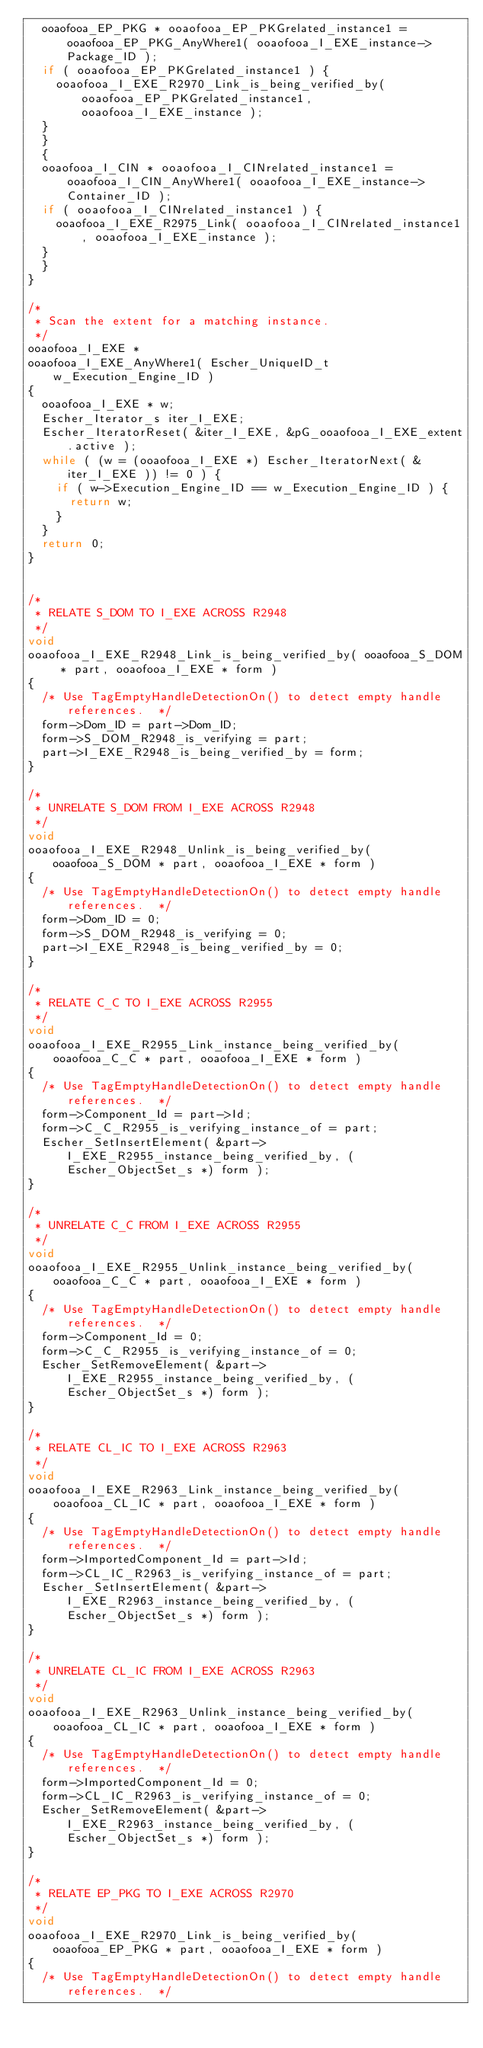<code> <loc_0><loc_0><loc_500><loc_500><_C_>  ooaofooa_EP_PKG * ooaofooa_EP_PKGrelated_instance1 = ooaofooa_EP_PKG_AnyWhere1( ooaofooa_I_EXE_instance->Package_ID );
  if ( ooaofooa_EP_PKGrelated_instance1 ) {
    ooaofooa_I_EXE_R2970_Link_is_being_verified_by( ooaofooa_EP_PKGrelated_instance1, ooaofooa_I_EXE_instance );
  }
  }
  {
  ooaofooa_I_CIN * ooaofooa_I_CINrelated_instance1 = ooaofooa_I_CIN_AnyWhere1( ooaofooa_I_EXE_instance->Container_ID );
  if ( ooaofooa_I_CINrelated_instance1 ) {
    ooaofooa_I_EXE_R2975_Link( ooaofooa_I_CINrelated_instance1, ooaofooa_I_EXE_instance );
  }
  }
}

/*
 * Scan the extent for a matching instance.
 */
ooaofooa_I_EXE *
ooaofooa_I_EXE_AnyWhere1( Escher_UniqueID_t w_Execution_Engine_ID )
{
  ooaofooa_I_EXE * w; 
  Escher_Iterator_s iter_I_EXE;
  Escher_IteratorReset( &iter_I_EXE, &pG_ooaofooa_I_EXE_extent.active );
  while ( (w = (ooaofooa_I_EXE *) Escher_IteratorNext( &iter_I_EXE )) != 0 ) {
    if ( w->Execution_Engine_ID == w_Execution_Engine_ID ) {
      return w;
    }
  }
  return 0;
}


/*
 * RELATE S_DOM TO I_EXE ACROSS R2948
 */
void
ooaofooa_I_EXE_R2948_Link_is_being_verified_by( ooaofooa_S_DOM * part, ooaofooa_I_EXE * form )
{
  /* Use TagEmptyHandleDetectionOn() to detect empty handle references.  */
  form->Dom_ID = part->Dom_ID;
  form->S_DOM_R2948_is_verifying = part;
  part->I_EXE_R2948_is_being_verified_by = form;
}

/*
 * UNRELATE S_DOM FROM I_EXE ACROSS R2948
 */
void
ooaofooa_I_EXE_R2948_Unlink_is_being_verified_by( ooaofooa_S_DOM * part, ooaofooa_I_EXE * form )
{
  /* Use TagEmptyHandleDetectionOn() to detect empty handle references.  */
  form->Dom_ID = 0;
  form->S_DOM_R2948_is_verifying = 0;
  part->I_EXE_R2948_is_being_verified_by = 0;
}

/*
 * RELATE C_C TO I_EXE ACROSS R2955
 */
void
ooaofooa_I_EXE_R2955_Link_instance_being_verified_by( ooaofooa_C_C * part, ooaofooa_I_EXE * form )
{
  /* Use TagEmptyHandleDetectionOn() to detect empty handle references.  */
  form->Component_Id = part->Id;
  form->C_C_R2955_is_verifying_instance_of = part;
  Escher_SetInsertElement( &part->I_EXE_R2955_instance_being_verified_by, (Escher_ObjectSet_s *) form );
}

/*
 * UNRELATE C_C FROM I_EXE ACROSS R2955
 */
void
ooaofooa_I_EXE_R2955_Unlink_instance_being_verified_by( ooaofooa_C_C * part, ooaofooa_I_EXE * form )
{
  /* Use TagEmptyHandleDetectionOn() to detect empty handle references.  */
  form->Component_Id = 0;
  form->C_C_R2955_is_verifying_instance_of = 0;
  Escher_SetRemoveElement( &part->I_EXE_R2955_instance_being_verified_by, (Escher_ObjectSet_s *) form );
}

/*
 * RELATE CL_IC TO I_EXE ACROSS R2963
 */
void
ooaofooa_I_EXE_R2963_Link_instance_being_verified_by( ooaofooa_CL_IC * part, ooaofooa_I_EXE * form )
{
  /* Use TagEmptyHandleDetectionOn() to detect empty handle references.  */
  form->ImportedComponent_Id = part->Id;
  form->CL_IC_R2963_is_verifying_instance_of = part;
  Escher_SetInsertElement( &part->I_EXE_R2963_instance_being_verified_by, (Escher_ObjectSet_s *) form );
}

/*
 * UNRELATE CL_IC FROM I_EXE ACROSS R2963
 */
void
ooaofooa_I_EXE_R2963_Unlink_instance_being_verified_by( ooaofooa_CL_IC * part, ooaofooa_I_EXE * form )
{
  /* Use TagEmptyHandleDetectionOn() to detect empty handle references.  */
  form->ImportedComponent_Id = 0;
  form->CL_IC_R2963_is_verifying_instance_of = 0;
  Escher_SetRemoveElement( &part->I_EXE_R2963_instance_being_verified_by, (Escher_ObjectSet_s *) form );
}

/*
 * RELATE EP_PKG TO I_EXE ACROSS R2970
 */
void
ooaofooa_I_EXE_R2970_Link_is_being_verified_by( ooaofooa_EP_PKG * part, ooaofooa_I_EXE * form )
{
  /* Use TagEmptyHandleDetectionOn() to detect empty handle references.  */</code> 